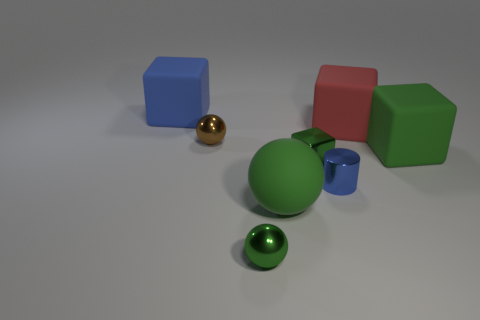Subtract all gray blocks. Subtract all blue cylinders. How many blocks are left? 4 Add 2 green cubes. How many objects exist? 10 Subtract all cylinders. How many objects are left? 7 Subtract all small green shiny spheres. Subtract all small red shiny things. How many objects are left? 7 Add 5 metal things. How many metal things are left? 9 Add 5 small metallic blocks. How many small metallic blocks exist? 6 Subtract 0 cyan balls. How many objects are left? 8 